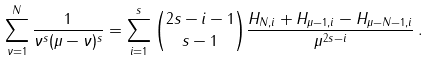Convert formula to latex. <formula><loc_0><loc_0><loc_500><loc_500>\sum _ { \nu = 1 } ^ { N } { \frac { 1 } { \nu ^ { s } ( \mu - \nu ) ^ { s } } } = \sum _ { i = 1 } ^ { s } { \binom { 2 s - i - 1 } { s - 1 } \frac { { H _ { N , i } + H _ { \mu - 1 , i } - H _ { \mu - N - 1 , i } } } { { \mu ^ { 2 s - i } } } } \, .</formula> 